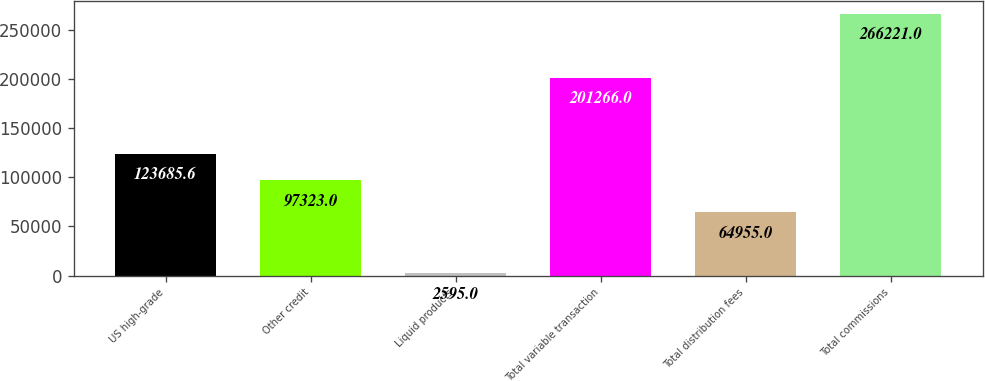Convert chart. <chart><loc_0><loc_0><loc_500><loc_500><bar_chart><fcel>US high-grade<fcel>Other credit<fcel>Liquid products<fcel>Total variable transaction<fcel>Total distribution fees<fcel>Total commissions<nl><fcel>123686<fcel>97323<fcel>2595<fcel>201266<fcel>64955<fcel>266221<nl></chart> 